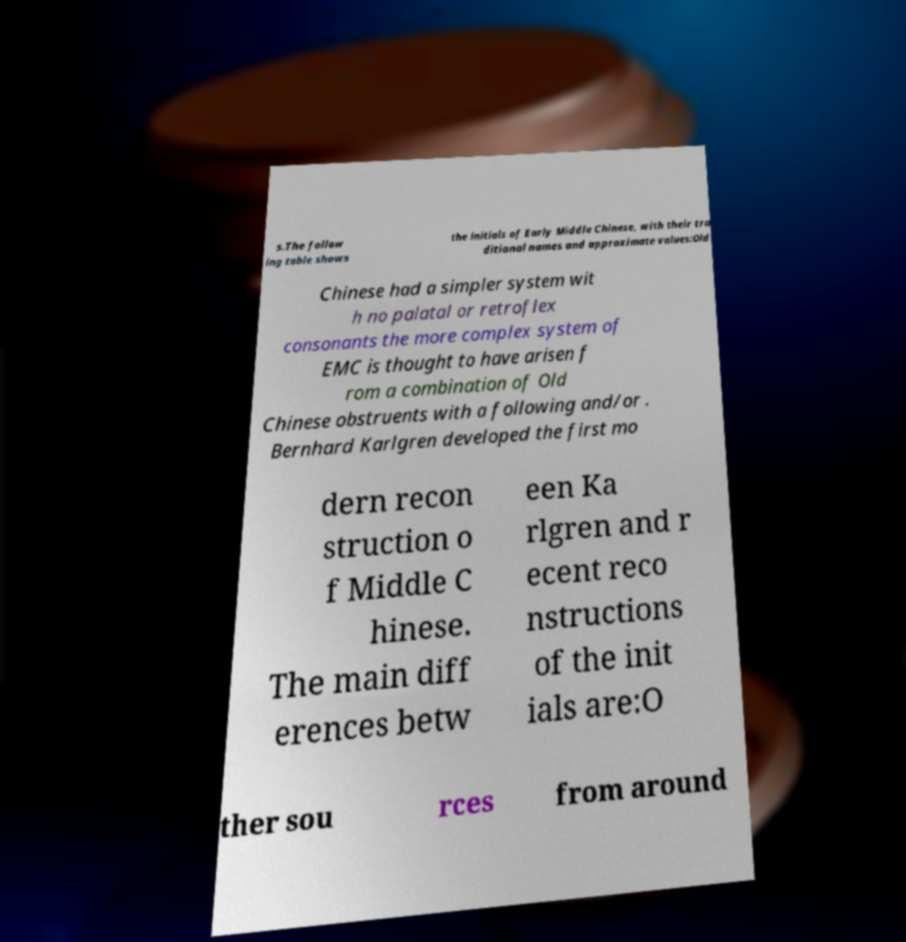I need the written content from this picture converted into text. Can you do that? s.The follow ing table shows the initials of Early Middle Chinese, with their tra ditional names and approximate values:Old Chinese had a simpler system wit h no palatal or retroflex consonants the more complex system of EMC is thought to have arisen f rom a combination of Old Chinese obstruents with a following and/or . Bernhard Karlgren developed the first mo dern recon struction o f Middle C hinese. The main diff erences betw een Ka rlgren and r ecent reco nstructions of the init ials are:O ther sou rces from around 